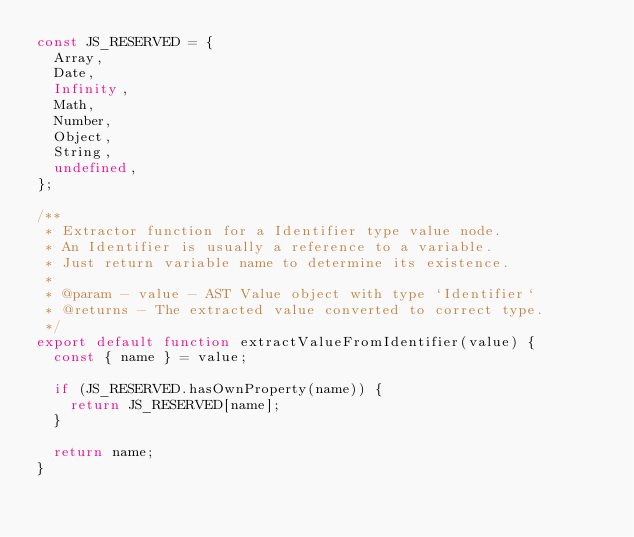<code> <loc_0><loc_0><loc_500><loc_500><_JavaScript_>const JS_RESERVED = {
  Array,
  Date,
  Infinity,
  Math,
  Number,
  Object,
  String,
  undefined,
};

/**
 * Extractor function for a Identifier type value node.
 * An Identifier is usually a reference to a variable.
 * Just return variable name to determine its existence.
 *
 * @param - value - AST Value object with type `Identifier`
 * @returns - The extracted value converted to correct type.
 */
export default function extractValueFromIdentifier(value) {
  const { name } = value;

  if (JS_RESERVED.hasOwnProperty(name)) {
    return JS_RESERVED[name];
  }

  return name;
}
</code> 